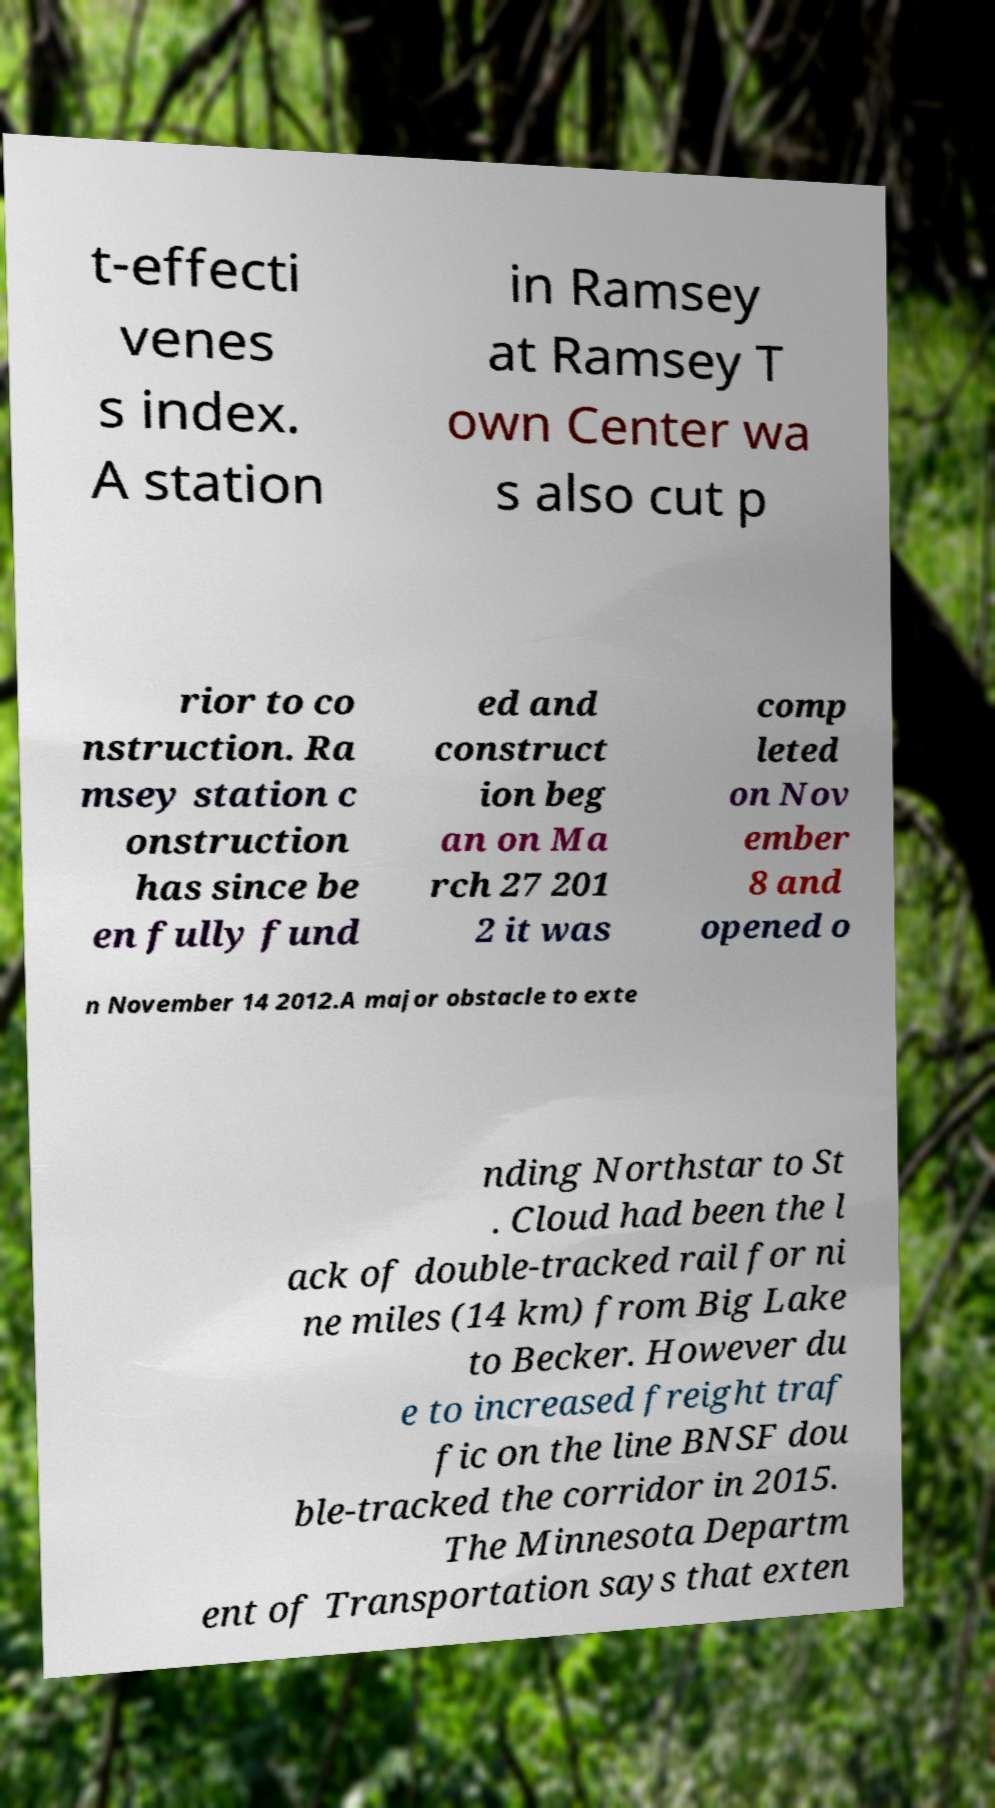For documentation purposes, I need the text within this image transcribed. Could you provide that? t-effecti venes s index. A station in Ramsey at Ramsey T own Center wa s also cut p rior to co nstruction. Ra msey station c onstruction has since be en fully fund ed and construct ion beg an on Ma rch 27 201 2 it was comp leted on Nov ember 8 and opened o n November 14 2012.A major obstacle to exte nding Northstar to St . Cloud had been the l ack of double-tracked rail for ni ne miles (14 km) from Big Lake to Becker. However du e to increased freight traf fic on the line BNSF dou ble-tracked the corridor in 2015. The Minnesota Departm ent of Transportation says that exten 